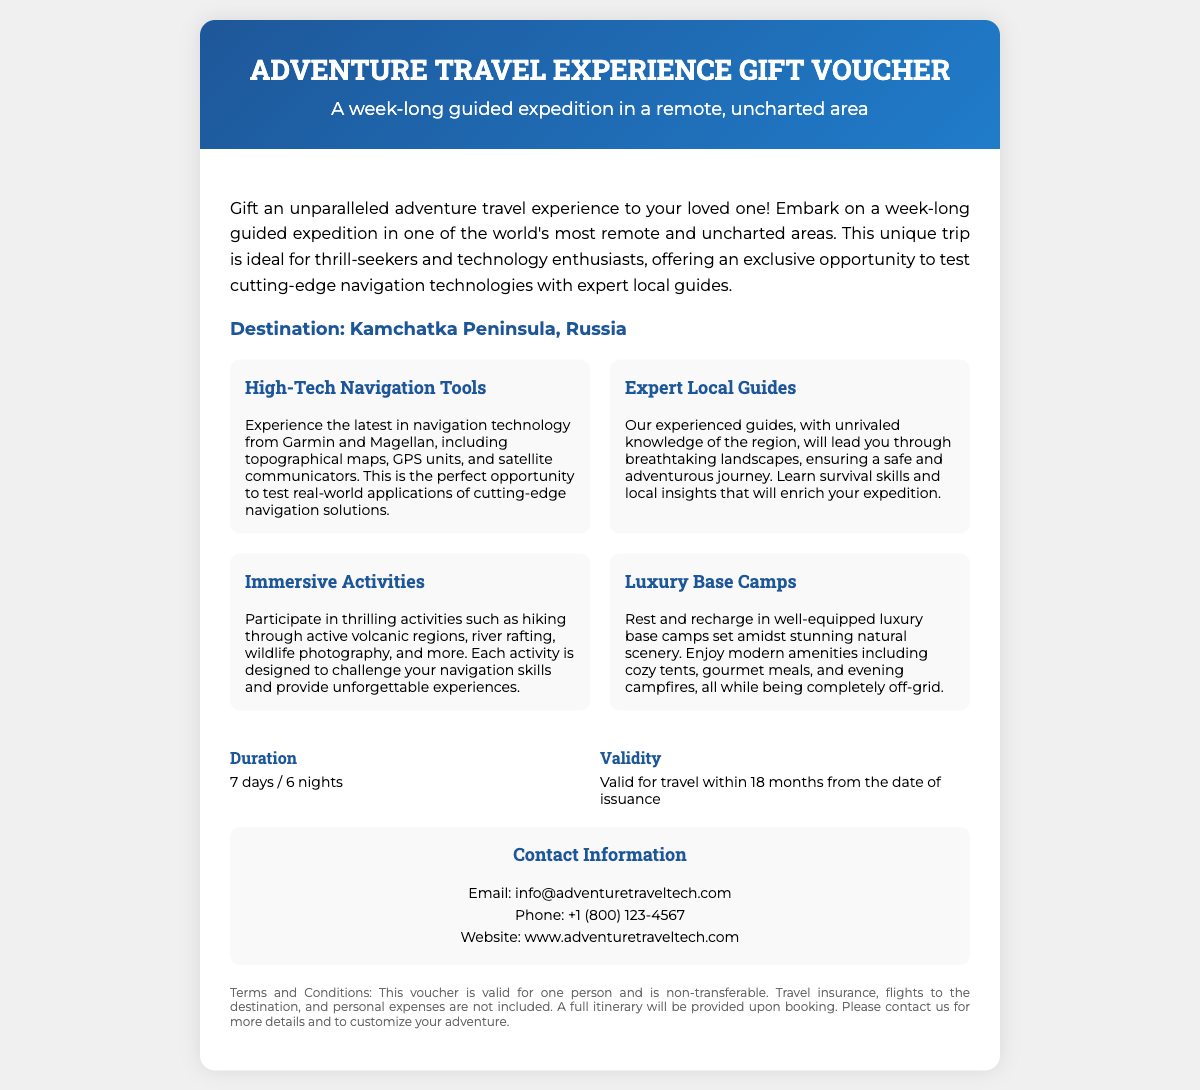What is the destination of the expedition? The destination is specified in the document as Kamchatka Peninsula, Russia.
Answer: Kamchatka Peninsula, Russia What is the duration of the trip? The duration is provided in the details section of the document, which states 7 days / 6 nights.
Answer: 7 days / 6 nights What is included in the luxury base camps? The document mentions modern amenities including cozy tents, gourmet meals, and evening campfires as part of the luxury base camps.
Answer: Cozy tents, gourmet meals, and evening campfires How long is the voucher valid for travel? The validity of the voucher is noted as valid for travel within 18 months from the date of issuance.
Answer: 18 months What types of activities are mentioned in the offer section? The activities listed include hiking, river rafting, wildlife photography, and more.
Answer: Hiking, river rafting, wildlife photography Who do you contact for more information? The contact information section provides an email and phone number to reach out for further details.
Answer: info@adventuretraveltech.com What types of navigation tools will be experienced? The document specifies that tools from Garmin and Magellan will be used during the expedition.
Answer: Garmin and Magellan What skills will the guides teach participants? The document mentions that participants will learn survival skills and local insights through the expert guides.
Answer: Survival skills and local insights 